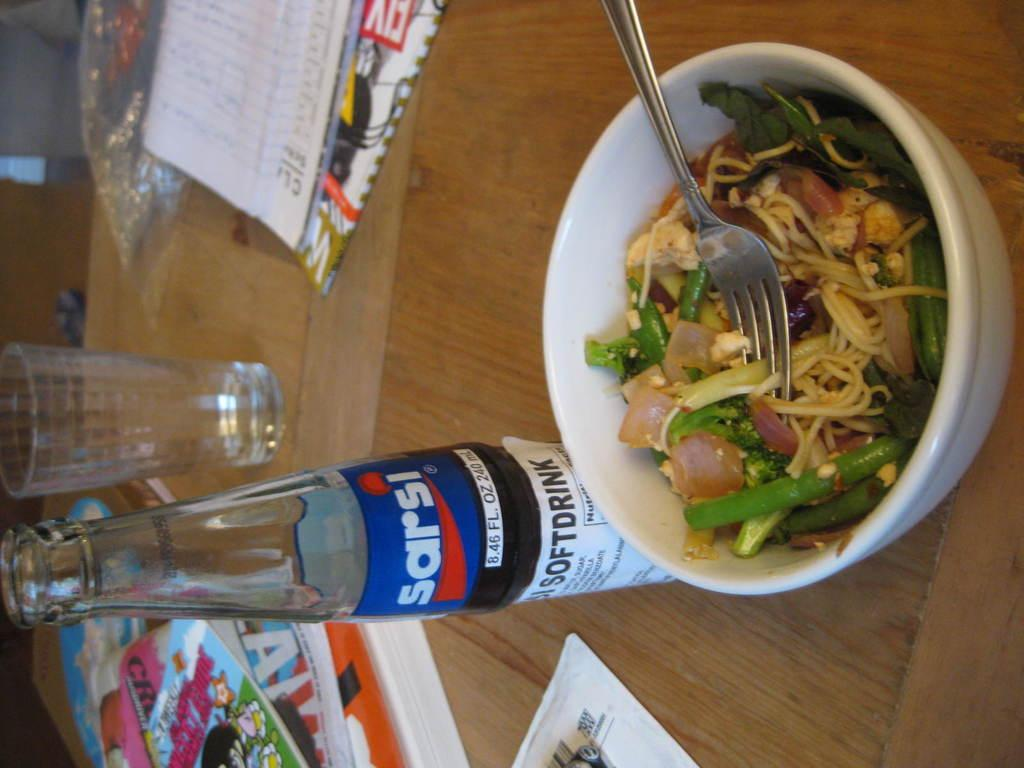What piece of furniture is present in the image? There is a table in the image. What is on the table? There is a bowl with food, a fork, a book, a glass, and a bottle on the table. What utensil is in the bowl with the food? There is a fork in the bowl with the food. What type of container is holding a liquid on the table? There is a glass and a bottle on the table, both of which can hold liquids. What type of pipe is visible on the table in the image? There is no pipe present on the table in the image. How many rings are on the fork in the bowl with the food? There are no rings on the fork in the bowl with the food; it is a standard fork without any decorations. 